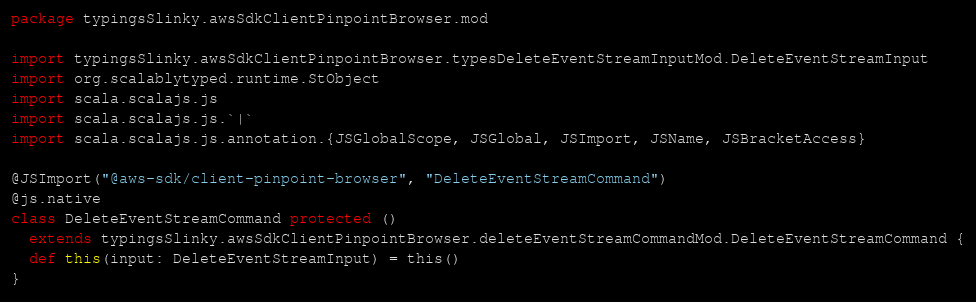Convert code to text. <code><loc_0><loc_0><loc_500><loc_500><_Scala_>package typingsSlinky.awsSdkClientPinpointBrowser.mod

import typingsSlinky.awsSdkClientPinpointBrowser.typesDeleteEventStreamInputMod.DeleteEventStreamInput
import org.scalablytyped.runtime.StObject
import scala.scalajs.js
import scala.scalajs.js.`|`
import scala.scalajs.js.annotation.{JSGlobalScope, JSGlobal, JSImport, JSName, JSBracketAccess}

@JSImport("@aws-sdk/client-pinpoint-browser", "DeleteEventStreamCommand")
@js.native
class DeleteEventStreamCommand protected ()
  extends typingsSlinky.awsSdkClientPinpointBrowser.deleteEventStreamCommandMod.DeleteEventStreamCommand {
  def this(input: DeleteEventStreamInput) = this()
}
</code> 